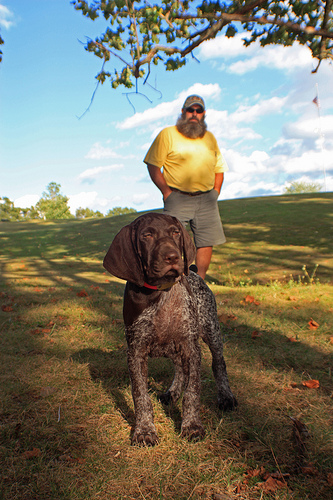Please provide a short description for this region: [0.52, 0.24, 0.59, 0.28]. Man has grey beard. Please provide the bounding box coordinate of the region this sentence describes: A dog. [0.38, 0.71, 0.61, 0.88] Please provide a short description for this region: [0.47, 0.24, 0.64, 0.38]. Man wearing t shirt. Please provide the bounding box coordinate of the region this sentence describes: He has a yellow shirt. [0.46, 0.2, 0.65, 0.4] Please provide the bounding box coordinate of the region this sentence describes: Man wearing gray ball cap. [0.52, 0.18, 0.59, 0.22] Please provide a short description for this region: [0.42, 0.23, 0.66, 0.53]. He has grey shorts. Please provide a short description for this region: [0.45, 0.17, 0.64, 0.56]. Man has sunglasses. Please provide a short description for this region: [0.49, 0.36, 0.63, 0.5]. Man wearing gray shorts. Please provide the bounding box coordinate of the region this sentence describes: A dog. [0.37, 0.51, 0.61, 0.86] Please provide a short description for this region: [0.44, 0.25, 0.63, 0.39]. Yellow shirt. 